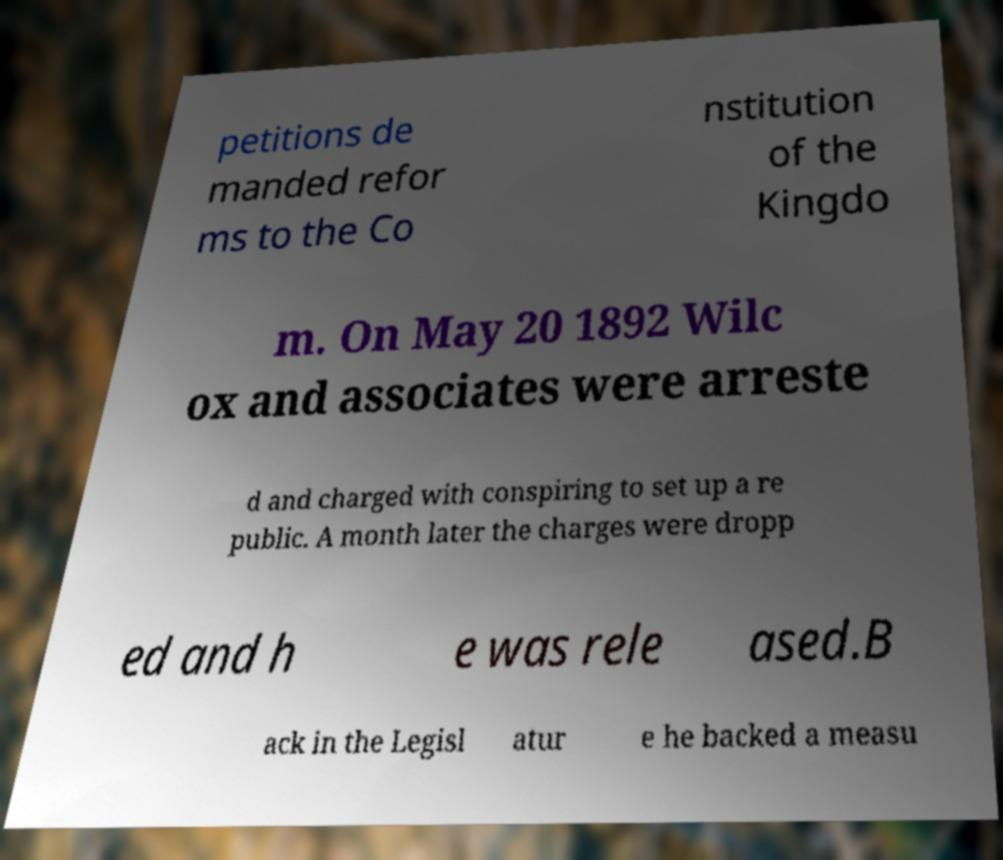Could you assist in decoding the text presented in this image and type it out clearly? petitions de manded refor ms to the Co nstitution of the Kingdo m. On May 20 1892 Wilc ox and associates were arreste d and charged with conspiring to set up a re public. A month later the charges were dropp ed and h e was rele ased.B ack in the Legisl atur e he backed a measu 